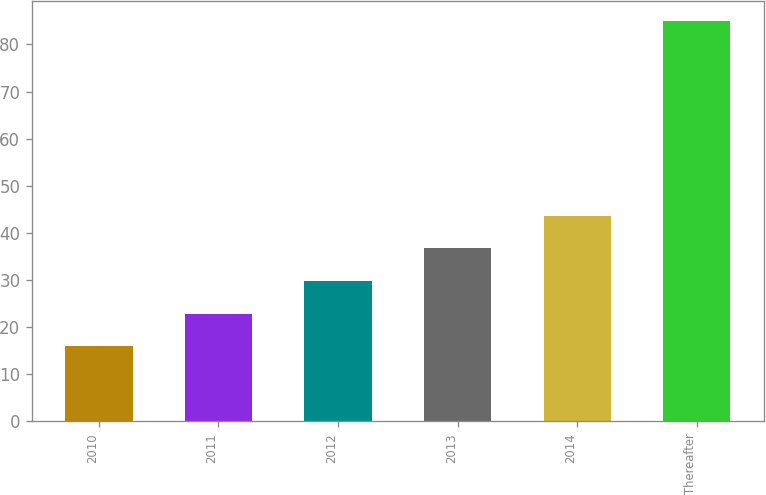Convert chart to OTSL. <chart><loc_0><loc_0><loc_500><loc_500><bar_chart><fcel>2010<fcel>2011<fcel>2012<fcel>2013<fcel>2014<fcel>Thereafter<nl><fcel>16<fcel>22.9<fcel>29.8<fcel>36.7<fcel>43.6<fcel>85<nl></chart> 